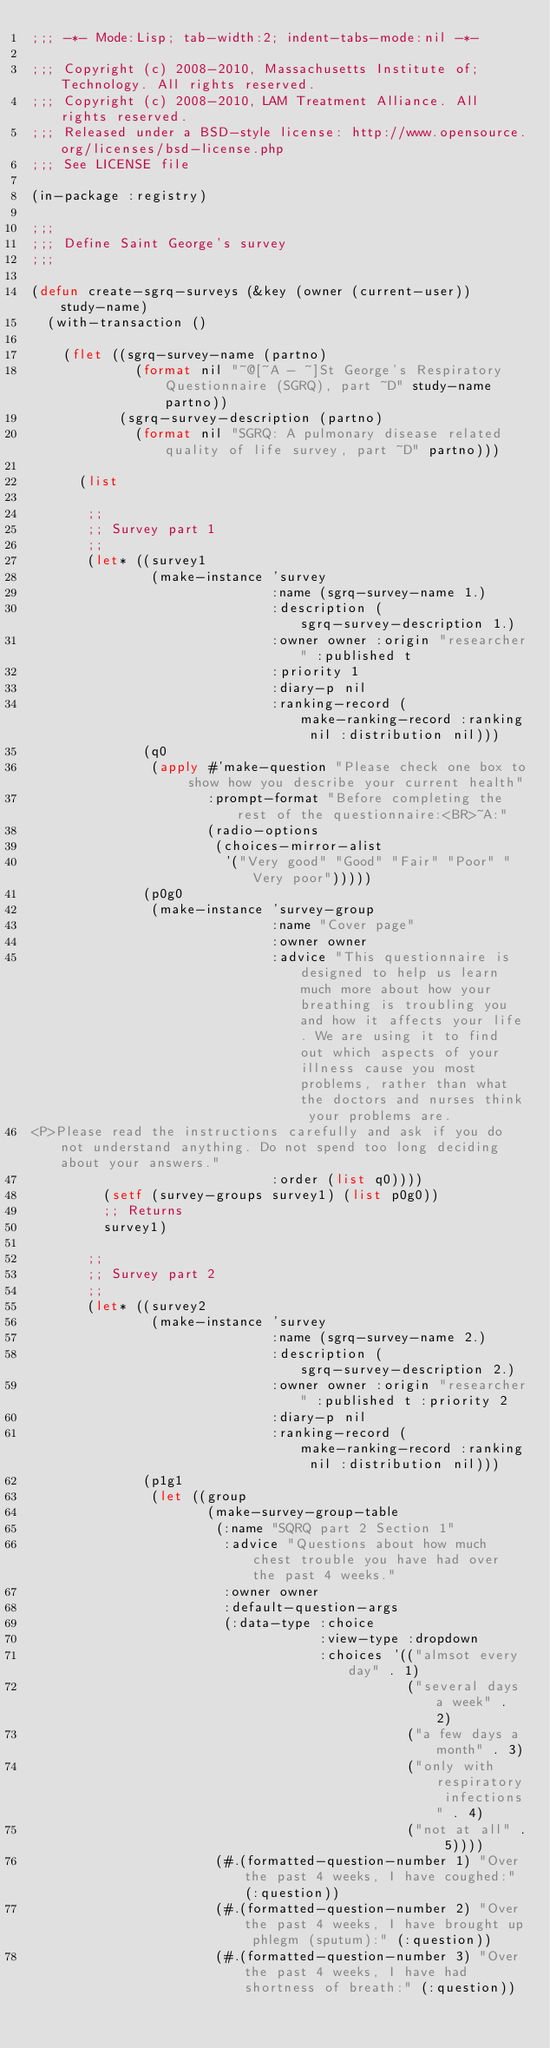Convert code to text. <code><loc_0><loc_0><loc_500><loc_500><_Lisp_>;;; -*- Mode:Lisp; tab-width:2; indent-tabs-mode:nil -*-

;;; Copyright (c) 2008-2010, Massachusetts Institute of;Technology. All rights reserved. 
;;; Copyright (c) 2008-2010, LAM Treatment Alliance. All rights reserved. 
;;; Released under a BSD-style license: http://www.opensource.org/licenses/bsd-license.php 
;;; See LICENSE file 

(in-package :registry)

;;;
;;; Define Saint George's survey
;;;

(defun create-sgrq-surveys (&key (owner (current-user)) study-name)
  (with-transaction ()

    (flet ((sgrq-survey-name (partno) 
             (format nil "~@[~A - ~]St George's Respiratory Questionnaire (SGRQ), part ~D" study-name partno))
           (sgrq-survey-description (partno) 
             (format nil "SGRQ: A pulmonary disease related quality of life survey, part ~D" partno)))

      (list

       ;;
       ;; Survey part 1
       ;;
       (let* ((survey1
               (make-instance 'survey
                              :name (sgrq-survey-name 1.)
                              :description (sgrq-survey-description 1.)
                              :owner owner :origin "researcher" :published t
                              :priority 1
                              :diary-p nil
                              :ranking-record (make-ranking-record :ranking nil :distribution nil)))
              (q0
               (apply #'make-question "Please check one box to show how you describe your current health"
                      :prompt-format "Before completing the rest of the questionnaire:<BR>~A:"
                      (radio-options
                       (choices-mirror-alist
                        '("Very good" "Good" "Fair" "Poor" "Very poor")))))
              (p0g0
               (make-instance 'survey-group
                              :name "Cover page"
                              :owner owner
                              :advice "This questionnaire is designed to help us learn much more about how your breathing is troubling you and how it affects your life. We are using it to find out which aspects of your illness cause you most problems, rather than what the doctors and nurses think your problems are.
<P>Please read the instructions carefully and ask if you do not understand anything. Do not spend too long deciding about your answers."
                              :order (list q0))))
         (setf (survey-groups survey1) (list p0g0))
         ;; Returns
         survey1)

       ;;
       ;; Survey part 2
       ;;
       (let* ((survey2
               (make-instance 'survey
                              :name (sgrq-survey-name 2.)
                              :description (sgrq-survey-description 2.)
                              :owner owner :origin "researcher" :published t :priority 2
                              :diary-p nil
                              :ranking-record (make-ranking-record :ranking nil :distribution nil)))
              (p1g1
               (let ((group
                      (make-survey-group-table
                       (:name "SQRQ part 2 Section 1"
                        :advice "Questions about how much chest trouble you have had over the past 4 weeks."
                        :owner owner
                        :default-question-args
                        (:data-type :choice
                                    :view-type :dropdown
                                    :choices '(("almsot every day" . 1)
                                               ("several days a week" . 2)
                                               ("a few days a month" . 3)
                                               ("only with respiratory infections" . 4)
                                               ("not at all" . 5))))
                       (#.(formatted-question-number 1) "Over the past 4 weeks, I have coughed:" (:question))
                       (#.(formatted-question-number 2) "Over the past 4 weeks, I have brought up phlegm (sputum):" (:question))
                       (#.(formatted-question-number 3) "Over the past 4 weeks, I have had shortness of breath:" (:question))</code> 